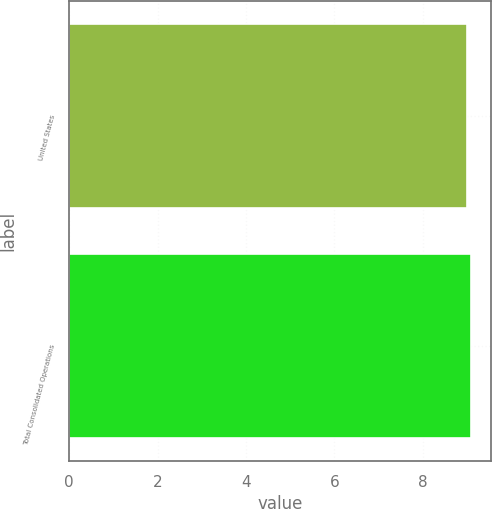Convert chart. <chart><loc_0><loc_0><loc_500><loc_500><bar_chart><fcel>United States<fcel>Total Consolidated Operations<nl><fcel>9<fcel>9.1<nl></chart> 